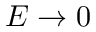Convert formula to latex. <formula><loc_0><loc_0><loc_500><loc_500>E \to 0</formula> 